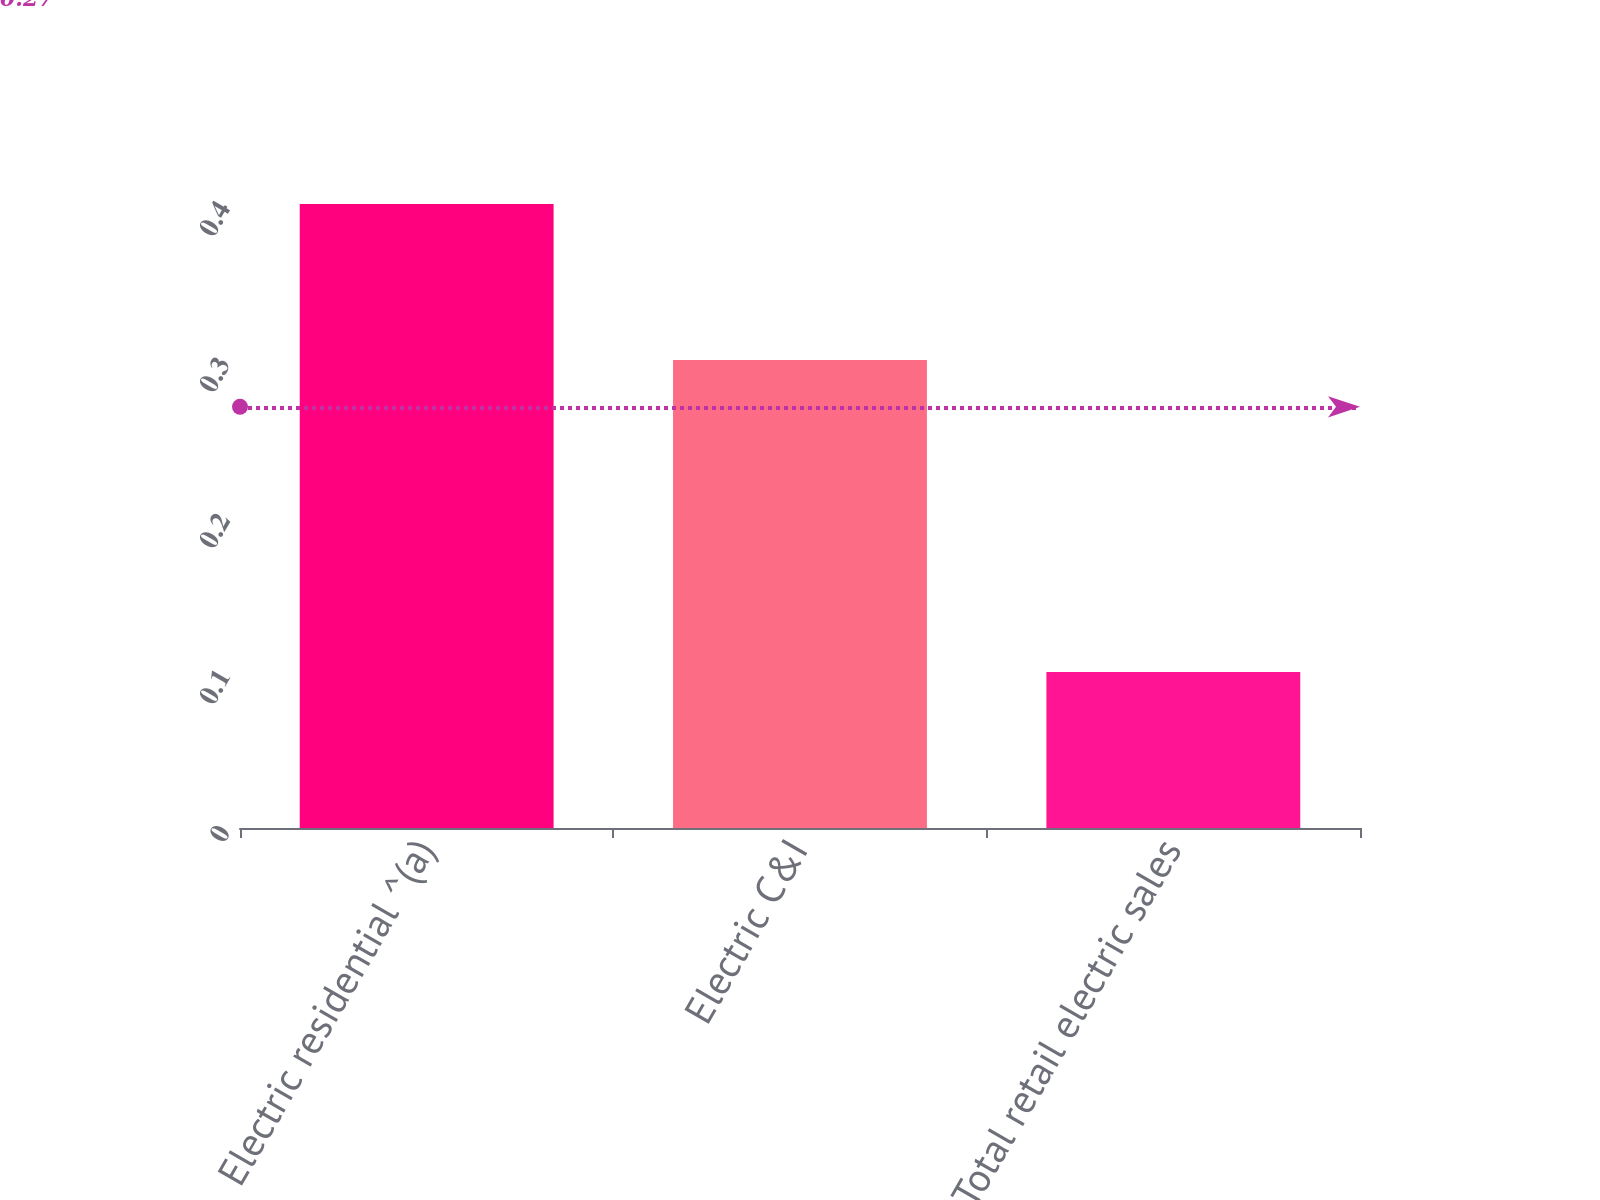Convert chart. <chart><loc_0><loc_0><loc_500><loc_500><bar_chart><fcel>Electric residential ^(a)<fcel>Electric C&I<fcel>Total retail electric sales<nl><fcel>0.4<fcel>0.3<fcel>0.1<nl></chart> 